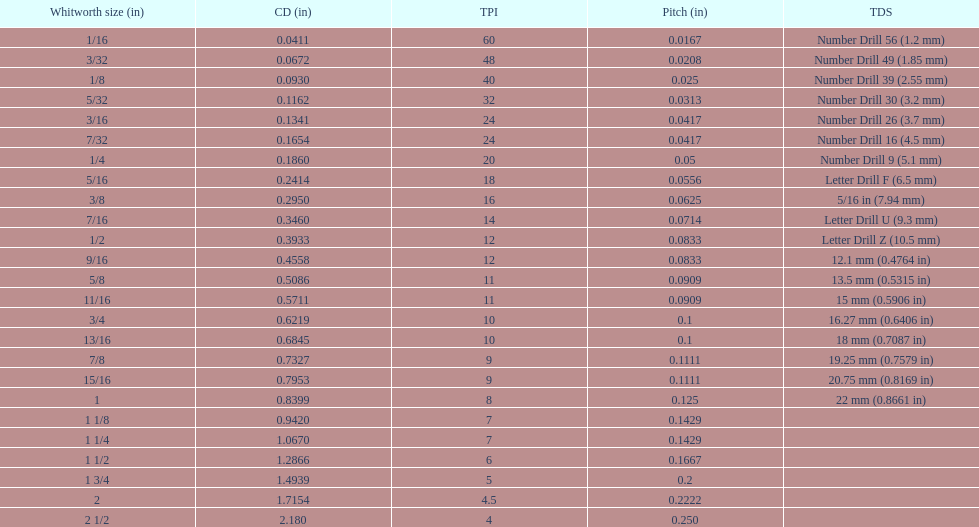How many more threads per inch does the 1/16th whitworth size have over the 1/8th whitworth size? 20. 